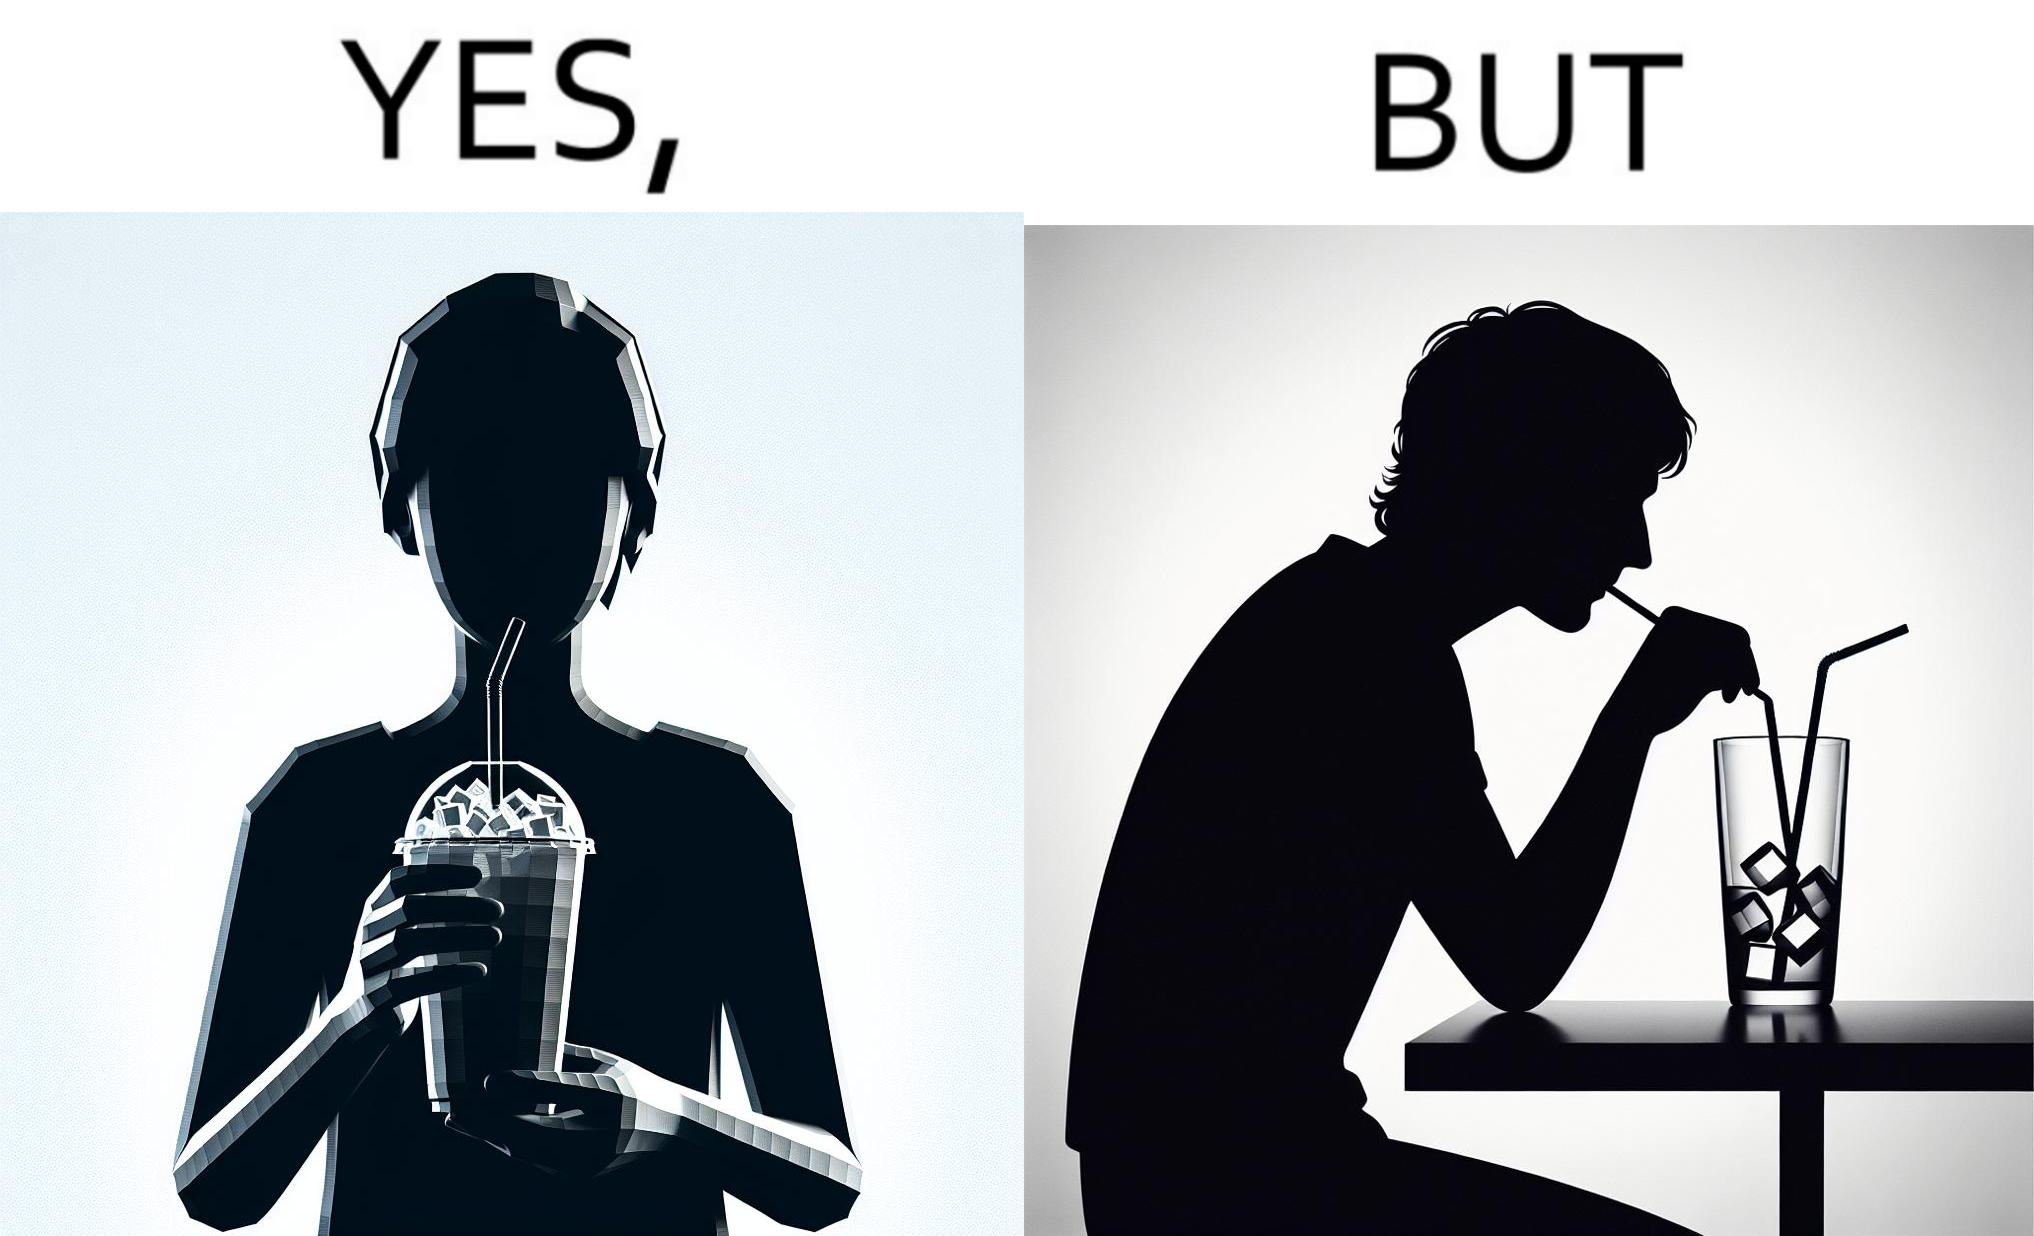What does this image depict? The image is funny, as the drink seems to be full to begin with, while most of the volume of the drink is occupied by the ice cubes. 